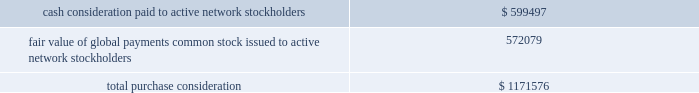Organizations evaluate whether transactions should be accounted for as acquisitions ( or disposals ) of assets or businesses , with the expectation that fewer will qualify as acquisitions ( or disposals ) of businesses .
The asu became effective for us on january 1 , 2018 .
These amendments will be applied prospectively from the date of adoption .
The effect of asu 2017-01 will be dependent upon the nature of future acquisitions or dispositions that we make , if any .
In october 2016 , the fasb issued asu 2016-16 , 201cincome taxes ( topic 740 ) : intra-entity transfers of assets other than inventory . 201d the amendments in this update state that an entity should recognize the income tax consequences of an intra-entity transfer of an asset other than inventory , such as intellectual property and property and equipment , when the transfer occurs .
We will adopt asu 2016-16 effective january 1 , 2018 with no expected effect on our consolidated financial statements .
In june 2016 , the fasb issued asu 2016-13 , 201cfinancial instruments - credit losses ( topic 326 ) : measurement of credit losses on financial instruments . 201d the amendments in this update change how companies measure and recognize credit impairment for many financial assets .
The new expected credit loss model will require companies to immediately recognize an estimate of credit losses expected to occur over the remaining life of the financial assets ( including trade receivables ) that are in the scope of the update .
The update also made amendments to the current impairment model for held-to-maturity and available-for-sale debt securities and certain guarantees .
The guidance will become effective for us on january 1 , 2020 .
Early adoption is permitted for periods beginning on or after january 1 , 2019 .
We are evaluating the effect of asu 2016-13 on our consolidated financial statements .
In january 2016 , the fasb issued asu 2016-01 , 201cfinancial instruments - overall ( subtopic 825-10 ) : recognition and measurement of financial assets and financial liabilities . 201d the amendments in this update address certain aspects of recognition , measurement , presentation and disclosure of financial instruments .
The amendments in this update supersede the guidance to classify equity securities with readily determinable fair values into different categories ( that is , trading or available-for-sale ) and require equity securities ( including other ownership interests , such as partnerships , unincorporated joint ventures and limited liability companies ) to be measured at fair value with changes in the fair value recognized through earnings .
Equity investments that are accounted for under the equity method of accounting or result in consolidation of an investee are not included within the scope of this update .
The amendments allow equity investments that do not have readily determinable fair values to be remeasured at fair value either upon the occurrence of an observable price change or upon identification of an impairment .
The amendments also require enhanced disclosures about those investments .
We will adopt asu 2016-01 effective january 1 , 2018 with no expected effect on our consolidated financial statements .
Note 2 2014 acquisitions active network we acquired the communities and sports divisions of athlaction topco , llc ( 201cactive network 201d ) on september 1 , 2017 , for total purchase consideration of $ 1.2 billion .
Active network delivers cloud-based enterprise software , including payment technology solutions , to event organizers in the communities and health and fitness markets .
This acquisition aligns with our technology-enabled , software driven strategy and adds an enterprise software business operating in two additional vertical markets that we believe offer attractive growth fundamentals .
The table summarizes the cash and non-cash components of the consideration transferred on september 1 , 2017 ( in thousands ) : .
We funded the cash portion of the total purchase consideration primarily by drawing on our revolving credit facility ( described in 201cnote 7 2014 long-term debt and lines of credit 201d ) .
The acquisition-date fair value of 72 2013 global payments inc .
| 2017 form 10-k annual report .
Based on the table , what was the fair value price of global payments common stock given to active network stockholders? 
Rationale: the valuation of the common stock would be $ 1 because the total amount of money issued subtracted by the cash consolidation . that remainder equals the same amount of shares which concludes that the share price would be $ 1 .
Computations: (572079 + 599497)
Answer: 1171576.0. Organizations evaluate whether transactions should be accounted for as acquisitions ( or disposals ) of assets or businesses , with the expectation that fewer will qualify as acquisitions ( or disposals ) of businesses .
The asu became effective for us on january 1 , 2018 .
These amendments will be applied prospectively from the date of adoption .
The effect of asu 2017-01 will be dependent upon the nature of future acquisitions or dispositions that we make , if any .
In october 2016 , the fasb issued asu 2016-16 , 201cincome taxes ( topic 740 ) : intra-entity transfers of assets other than inventory . 201d the amendments in this update state that an entity should recognize the income tax consequences of an intra-entity transfer of an asset other than inventory , such as intellectual property and property and equipment , when the transfer occurs .
We will adopt asu 2016-16 effective january 1 , 2018 with no expected effect on our consolidated financial statements .
In june 2016 , the fasb issued asu 2016-13 , 201cfinancial instruments - credit losses ( topic 326 ) : measurement of credit losses on financial instruments . 201d the amendments in this update change how companies measure and recognize credit impairment for many financial assets .
The new expected credit loss model will require companies to immediately recognize an estimate of credit losses expected to occur over the remaining life of the financial assets ( including trade receivables ) that are in the scope of the update .
The update also made amendments to the current impairment model for held-to-maturity and available-for-sale debt securities and certain guarantees .
The guidance will become effective for us on january 1 , 2020 .
Early adoption is permitted for periods beginning on or after january 1 , 2019 .
We are evaluating the effect of asu 2016-13 on our consolidated financial statements .
In january 2016 , the fasb issued asu 2016-01 , 201cfinancial instruments - overall ( subtopic 825-10 ) : recognition and measurement of financial assets and financial liabilities . 201d the amendments in this update address certain aspects of recognition , measurement , presentation and disclosure of financial instruments .
The amendments in this update supersede the guidance to classify equity securities with readily determinable fair values into different categories ( that is , trading or available-for-sale ) and require equity securities ( including other ownership interests , such as partnerships , unincorporated joint ventures and limited liability companies ) to be measured at fair value with changes in the fair value recognized through earnings .
Equity investments that are accounted for under the equity method of accounting or result in consolidation of an investee are not included within the scope of this update .
The amendments allow equity investments that do not have readily determinable fair values to be remeasured at fair value either upon the occurrence of an observable price change or upon identification of an impairment .
The amendments also require enhanced disclosures about those investments .
We will adopt asu 2016-01 effective january 1 , 2018 with no expected effect on our consolidated financial statements .
Note 2 2014 acquisitions active network we acquired the communities and sports divisions of athlaction topco , llc ( 201cactive network 201d ) on september 1 , 2017 , for total purchase consideration of $ 1.2 billion .
Active network delivers cloud-based enterprise software , including payment technology solutions , to event organizers in the communities and health and fitness markets .
This acquisition aligns with our technology-enabled , software driven strategy and adds an enterprise software business operating in two additional vertical markets that we believe offer attractive growth fundamentals .
The table summarizes the cash and non-cash components of the consideration transferred on september 1 , 2017 ( in thousands ) : .
We funded the cash portion of the total purchase consideration primarily by drawing on our revolving credit facility ( described in 201cnote 7 2014 long-term debt and lines of credit 201d ) .
The acquisition-date fair value of 72 2013 global payments inc .
| 2017 form 10-k annual report .
What portion of the total purchase consideration is compensated with shares of global payments? 
Computations: (572079 / 1171576)
Answer: 0.4883. 